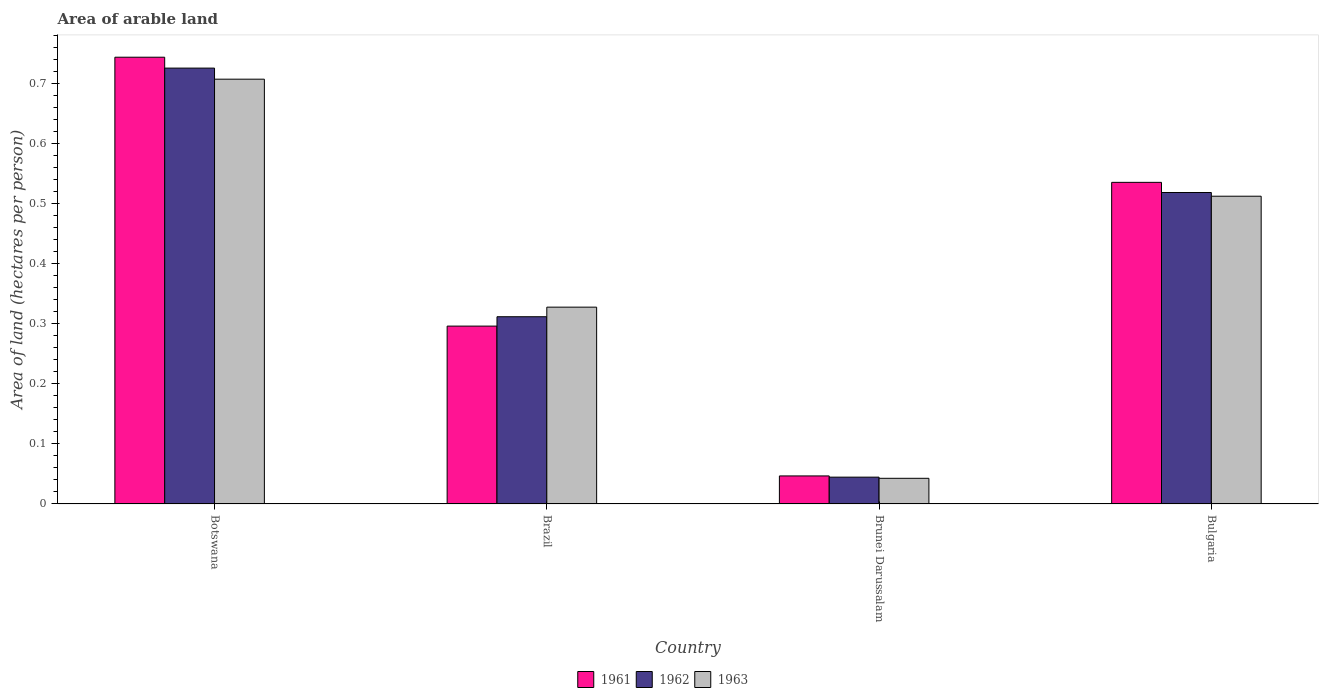How many groups of bars are there?
Make the answer very short. 4. What is the label of the 4th group of bars from the left?
Keep it short and to the point. Bulgaria. What is the total arable land in 1961 in Brunei Darussalam?
Keep it short and to the point. 0.05. Across all countries, what is the maximum total arable land in 1961?
Keep it short and to the point. 0.74. Across all countries, what is the minimum total arable land in 1962?
Offer a very short reply. 0.04. In which country was the total arable land in 1962 maximum?
Make the answer very short. Botswana. In which country was the total arable land in 1962 minimum?
Your answer should be compact. Brunei Darussalam. What is the total total arable land in 1963 in the graph?
Make the answer very short. 1.59. What is the difference between the total arable land in 1962 in Brazil and that in Brunei Darussalam?
Offer a terse response. 0.27. What is the difference between the total arable land in 1962 in Brazil and the total arable land in 1961 in Bulgaria?
Offer a terse response. -0.22. What is the average total arable land in 1961 per country?
Offer a terse response. 0.41. What is the difference between the total arable land of/in 1962 and total arable land of/in 1961 in Brazil?
Offer a very short reply. 0.02. In how many countries, is the total arable land in 1962 greater than 0.04 hectares per person?
Offer a terse response. 4. What is the ratio of the total arable land in 1962 in Botswana to that in Brazil?
Keep it short and to the point. 2.33. What is the difference between the highest and the second highest total arable land in 1963?
Offer a very short reply. 0.19. What is the difference between the highest and the lowest total arable land in 1961?
Your answer should be very brief. 0.7. Is it the case that in every country, the sum of the total arable land in 1962 and total arable land in 1963 is greater than the total arable land in 1961?
Provide a succinct answer. Yes. How many bars are there?
Make the answer very short. 12. Are all the bars in the graph horizontal?
Your response must be concise. No. Does the graph contain any zero values?
Ensure brevity in your answer.  No. Does the graph contain grids?
Your answer should be very brief. No. How many legend labels are there?
Offer a very short reply. 3. What is the title of the graph?
Provide a succinct answer. Area of arable land. Does "1981" appear as one of the legend labels in the graph?
Provide a succinct answer. No. What is the label or title of the X-axis?
Provide a succinct answer. Country. What is the label or title of the Y-axis?
Ensure brevity in your answer.  Area of land (hectares per person). What is the Area of land (hectares per person) in 1961 in Botswana?
Offer a terse response. 0.74. What is the Area of land (hectares per person) in 1962 in Botswana?
Your answer should be compact. 0.73. What is the Area of land (hectares per person) of 1963 in Botswana?
Ensure brevity in your answer.  0.71. What is the Area of land (hectares per person) in 1961 in Brazil?
Keep it short and to the point. 0.3. What is the Area of land (hectares per person) in 1962 in Brazil?
Give a very brief answer. 0.31. What is the Area of land (hectares per person) of 1963 in Brazil?
Provide a short and direct response. 0.33. What is the Area of land (hectares per person) of 1961 in Brunei Darussalam?
Give a very brief answer. 0.05. What is the Area of land (hectares per person) of 1962 in Brunei Darussalam?
Provide a succinct answer. 0.04. What is the Area of land (hectares per person) in 1963 in Brunei Darussalam?
Provide a succinct answer. 0.04. What is the Area of land (hectares per person) of 1961 in Bulgaria?
Ensure brevity in your answer.  0.54. What is the Area of land (hectares per person) of 1962 in Bulgaria?
Provide a succinct answer. 0.52. What is the Area of land (hectares per person) of 1963 in Bulgaria?
Make the answer very short. 0.51. Across all countries, what is the maximum Area of land (hectares per person) in 1961?
Give a very brief answer. 0.74. Across all countries, what is the maximum Area of land (hectares per person) of 1962?
Your response must be concise. 0.73. Across all countries, what is the maximum Area of land (hectares per person) in 1963?
Keep it short and to the point. 0.71. Across all countries, what is the minimum Area of land (hectares per person) in 1961?
Your answer should be compact. 0.05. Across all countries, what is the minimum Area of land (hectares per person) in 1962?
Make the answer very short. 0.04. Across all countries, what is the minimum Area of land (hectares per person) of 1963?
Give a very brief answer. 0.04. What is the total Area of land (hectares per person) of 1961 in the graph?
Offer a very short reply. 1.62. What is the total Area of land (hectares per person) of 1962 in the graph?
Make the answer very short. 1.6. What is the total Area of land (hectares per person) of 1963 in the graph?
Offer a terse response. 1.59. What is the difference between the Area of land (hectares per person) in 1961 in Botswana and that in Brazil?
Provide a succinct answer. 0.45. What is the difference between the Area of land (hectares per person) of 1962 in Botswana and that in Brazil?
Make the answer very short. 0.41. What is the difference between the Area of land (hectares per person) of 1963 in Botswana and that in Brazil?
Ensure brevity in your answer.  0.38. What is the difference between the Area of land (hectares per person) of 1961 in Botswana and that in Brunei Darussalam?
Keep it short and to the point. 0.7. What is the difference between the Area of land (hectares per person) in 1962 in Botswana and that in Brunei Darussalam?
Provide a succinct answer. 0.68. What is the difference between the Area of land (hectares per person) in 1963 in Botswana and that in Brunei Darussalam?
Give a very brief answer. 0.66. What is the difference between the Area of land (hectares per person) of 1961 in Botswana and that in Bulgaria?
Provide a short and direct response. 0.21. What is the difference between the Area of land (hectares per person) of 1962 in Botswana and that in Bulgaria?
Give a very brief answer. 0.21. What is the difference between the Area of land (hectares per person) in 1963 in Botswana and that in Bulgaria?
Your answer should be very brief. 0.19. What is the difference between the Area of land (hectares per person) of 1961 in Brazil and that in Brunei Darussalam?
Offer a very short reply. 0.25. What is the difference between the Area of land (hectares per person) of 1962 in Brazil and that in Brunei Darussalam?
Make the answer very short. 0.27. What is the difference between the Area of land (hectares per person) in 1963 in Brazil and that in Brunei Darussalam?
Your response must be concise. 0.28. What is the difference between the Area of land (hectares per person) in 1961 in Brazil and that in Bulgaria?
Provide a succinct answer. -0.24. What is the difference between the Area of land (hectares per person) of 1962 in Brazil and that in Bulgaria?
Your answer should be very brief. -0.21. What is the difference between the Area of land (hectares per person) of 1963 in Brazil and that in Bulgaria?
Give a very brief answer. -0.18. What is the difference between the Area of land (hectares per person) in 1961 in Brunei Darussalam and that in Bulgaria?
Provide a short and direct response. -0.49. What is the difference between the Area of land (hectares per person) in 1962 in Brunei Darussalam and that in Bulgaria?
Provide a succinct answer. -0.47. What is the difference between the Area of land (hectares per person) of 1963 in Brunei Darussalam and that in Bulgaria?
Provide a short and direct response. -0.47. What is the difference between the Area of land (hectares per person) in 1961 in Botswana and the Area of land (hectares per person) in 1962 in Brazil?
Your answer should be compact. 0.43. What is the difference between the Area of land (hectares per person) in 1961 in Botswana and the Area of land (hectares per person) in 1963 in Brazil?
Offer a very short reply. 0.42. What is the difference between the Area of land (hectares per person) of 1962 in Botswana and the Area of land (hectares per person) of 1963 in Brazil?
Your response must be concise. 0.4. What is the difference between the Area of land (hectares per person) of 1961 in Botswana and the Area of land (hectares per person) of 1962 in Brunei Darussalam?
Your response must be concise. 0.7. What is the difference between the Area of land (hectares per person) of 1961 in Botswana and the Area of land (hectares per person) of 1963 in Brunei Darussalam?
Your answer should be very brief. 0.7. What is the difference between the Area of land (hectares per person) of 1962 in Botswana and the Area of land (hectares per person) of 1963 in Brunei Darussalam?
Provide a short and direct response. 0.68. What is the difference between the Area of land (hectares per person) of 1961 in Botswana and the Area of land (hectares per person) of 1962 in Bulgaria?
Your answer should be very brief. 0.23. What is the difference between the Area of land (hectares per person) of 1961 in Botswana and the Area of land (hectares per person) of 1963 in Bulgaria?
Keep it short and to the point. 0.23. What is the difference between the Area of land (hectares per person) of 1962 in Botswana and the Area of land (hectares per person) of 1963 in Bulgaria?
Provide a short and direct response. 0.21. What is the difference between the Area of land (hectares per person) in 1961 in Brazil and the Area of land (hectares per person) in 1962 in Brunei Darussalam?
Make the answer very short. 0.25. What is the difference between the Area of land (hectares per person) of 1961 in Brazil and the Area of land (hectares per person) of 1963 in Brunei Darussalam?
Ensure brevity in your answer.  0.25. What is the difference between the Area of land (hectares per person) in 1962 in Brazil and the Area of land (hectares per person) in 1963 in Brunei Darussalam?
Your response must be concise. 0.27. What is the difference between the Area of land (hectares per person) of 1961 in Brazil and the Area of land (hectares per person) of 1962 in Bulgaria?
Your answer should be very brief. -0.22. What is the difference between the Area of land (hectares per person) of 1961 in Brazil and the Area of land (hectares per person) of 1963 in Bulgaria?
Give a very brief answer. -0.22. What is the difference between the Area of land (hectares per person) of 1962 in Brazil and the Area of land (hectares per person) of 1963 in Bulgaria?
Ensure brevity in your answer.  -0.2. What is the difference between the Area of land (hectares per person) in 1961 in Brunei Darussalam and the Area of land (hectares per person) in 1962 in Bulgaria?
Give a very brief answer. -0.47. What is the difference between the Area of land (hectares per person) of 1961 in Brunei Darussalam and the Area of land (hectares per person) of 1963 in Bulgaria?
Offer a terse response. -0.47. What is the difference between the Area of land (hectares per person) in 1962 in Brunei Darussalam and the Area of land (hectares per person) in 1963 in Bulgaria?
Give a very brief answer. -0.47. What is the average Area of land (hectares per person) in 1961 per country?
Your answer should be compact. 0.41. What is the average Area of land (hectares per person) of 1962 per country?
Provide a succinct answer. 0.4. What is the average Area of land (hectares per person) in 1963 per country?
Offer a very short reply. 0.4. What is the difference between the Area of land (hectares per person) of 1961 and Area of land (hectares per person) of 1962 in Botswana?
Offer a very short reply. 0.02. What is the difference between the Area of land (hectares per person) of 1961 and Area of land (hectares per person) of 1963 in Botswana?
Make the answer very short. 0.04. What is the difference between the Area of land (hectares per person) in 1962 and Area of land (hectares per person) in 1963 in Botswana?
Your answer should be very brief. 0.02. What is the difference between the Area of land (hectares per person) of 1961 and Area of land (hectares per person) of 1962 in Brazil?
Your answer should be compact. -0.02. What is the difference between the Area of land (hectares per person) of 1961 and Area of land (hectares per person) of 1963 in Brazil?
Provide a succinct answer. -0.03. What is the difference between the Area of land (hectares per person) in 1962 and Area of land (hectares per person) in 1963 in Brazil?
Offer a terse response. -0.02. What is the difference between the Area of land (hectares per person) of 1961 and Area of land (hectares per person) of 1962 in Brunei Darussalam?
Provide a short and direct response. 0. What is the difference between the Area of land (hectares per person) of 1961 and Area of land (hectares per person) of 1963 in Brunei Darussalam?
Offer a terse response. 0. What is the difference between the Area of land (hectares per person) in 1962 and Area of land (hectares per person) in 1963 in Brunei Darussalam?
Your answer should be compact. 0. What is the difference between the Area of land (hectares per person) in 1961 and Area of land (hectares per person) in 1962 in Bulgaria?
Provide a short and direct response. 0.02. What is the difference between the Area of land (hectares per person) in 1961 and Area of land (hectares per person) in 1963 in Bulgaria?
Your answer should be compact. 0.02. What is the difference between the Area of land (hectares per person) in 1962 and Area of land (hectares per person) in 1963 in Bulgaria?
Your response must be concise. 0.01. What is the ratio of the Area of land (hectares per person) in 1961 in Botswana to that in Brazil?
Your answer should be compact. 2.51. What is the ratio of the Area of land (hectares per person) in 1962 in Botswana to that in Brazil?
Your response must be concise. 2.33. What is the ratio of the Area of land (hectares per person) in 1963 in Botswana to that in Brazil?
Your answer should be compact. 2.16. What is the ratio of the Area of land (hectares per person) of 1961 in Botswana to that in Brunei Darussalam?
Ensure brevity in your answer.  15.93. What is the ratio of the Area of land (hectares per person) in 1962 in Botswana to that in Brunei Darussalam?
Provide a short and direct response. 16.25. What is the ratio of the Area of land (hectares per person) in 1963 in Botswana to that in Brunei Darussalam?
Provide a short and direct response. 16.55. What is the ratio of the Area of land (hectares per person) in 1961 in Botswana to that in Bulgaria?
Offer a very short reply. 1.39. What is the ratio of the Area of land (hectares per person) in 1962 in Botswana to that in Bulgaria?
Keep it short and to the point. 1.4. What is the ratio of the Area of land (hectares per person) of 1963 in Botswana to that in Bulgaria?
Offer a terse response. 1.38. What is the ratio of the Area of land (hectares per person) in 1961 in Brazil to that in Brunei Darussalam?
Your answer should be very brief. 6.34. What is the ratio of the Area of land (hectares per person) of 1962 in Brazil to that in Brunei Darussalam?
Provide a succinct answer. 6.98. What is the ratio of the Area of land (hectares per person) of 1963 in Brazil to that in Brunei Darussalam?
Offer a terse response. 7.67. What is the ratio of the Area of land (hectares per person) in 1961 in Brazil to that in Bulgaria?
Your answer should be compact. 0.55. What is the ratio of the Area of land (hectares per person) in 1962 in Brazil to that in Bulgaria?
Offer a very short reply. 0.6. What is the ratio of the Area of land (hectares per person) of 1963 in Brazil to that in Bulgaria?
Your response must be concise. 0.64. What is the ratio of the Area of land (hectares per person) of 1961 in Brunei Darussalam to that in Bulgaria?
Your answer should be very brief. 0.09. What is the ratio of the Area of land (hectares per person) of 1962 in Brunei Darussalam to that in Bulgaria?
Give a very brief answer. 0.09. What is the ratio of the Area of land (hectares per person) in 1963 in Brunei Darussalam to that in Bulgaria?
Your response must be concise. 0.08. What is the difference between the highest and the second highest Area of land (hectares per person) in 1961?
Your answer should be very brief. 0.21. What is the difference between the highest and the second highest Area of land (hectares per person) of 1962?
Give a very brief answer. 0.21. What is the difference between the highest and the second highest Area of land (hectares per person) of 1963?
Ensure brevity in your answer.  0.19. What is the difference between the highest and the lowest Area of land (hectares per person) in 1961?
Provide a short and direct response. 0.7. What is the difference between the highest and the lowest Area of land (hectares per person) of 1962?
Make the answer very short. 0.68. What is the difference between the highest and the lowest Area of land (hectares per person) of 1963?
Offer a terse response. 0.66. 